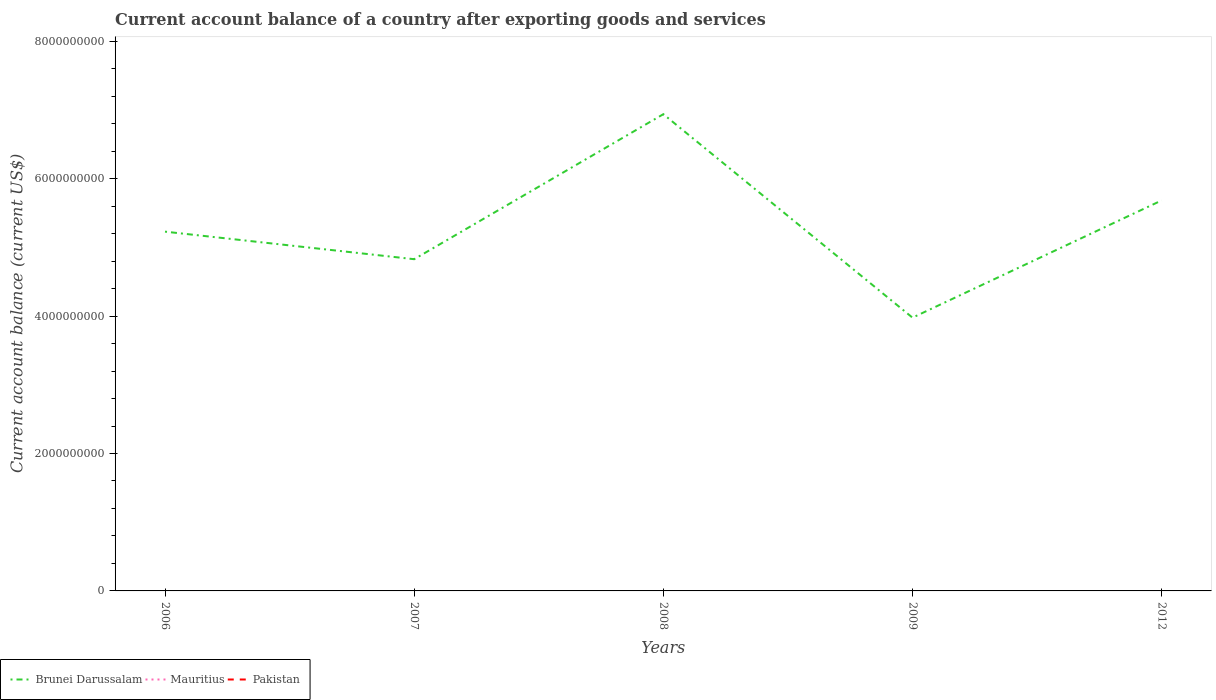How many different coloured lines are there?
Your response must be concise. 1. What is the total account balance in Brunei Darussalam in the graph?
Offer a terse response. -4.55e+08. What is the difference between the highest and the second highest account balance in Brunei Darussalam?
Your answer should be very brief. 2.96e+09. Is the account balance in Mauritius strictly greater than the account balance in Pakistan over the years?
Your response must be concise. No. How many lines are there?
Your answer should be compact. 1. How many years are there in the graph?
Your answer should be compact. 5. What is the difference between two consecutive major ticks on the Y-axis?
Offer a very short reply. 2.00e+09. Are the values on the major ticks of Y-axis written in scientific E-notation?
Provide a short and direct response. No. Does the graph contain any zero values?
Keep it short and to the point. Yes. How are the legend labels stacked?
Offer a very short reply. Horizontal. What is the title of the graph?
Make the answer very short. Current account balance of a country after exporting goods and services. What is the label or title of the X-axis?
Offer a very short reply. Years. What is the label or title of the Y-axis?
Your answer should be compact. Current account balance (current US$). What is the Current account balance (current US$) of Brunei Darussalam in 2006?
Offer a very short reply. 5.23e+09. What is the Current account balance (current US$) in Pakistan in 2006?
Your answer should be very brief. 0. What is the Current account balance (current US$) in Brunei Darussalam in 2007?
Offer a very short reply. 4.83e+09. What is the Current account balance (current US$) of Mauritius in 2007?
Your answer should be very brief. 0. What is the Current account balance (current US$) in Pakistan in 2007?
Ensure brevity in your answer.  0. What is the Current account balance (current US$) of Brunei Darussalam in 2008?
Your response must be concise. 6.94e+09. What is the Current account balance (current US$) in Brunei Darussalam in 2009?
Offer a very short reply. 3.98e+09. What is the Current account balance (current US$) of Pakistan in 2009?
Offer a terse response. 0. What is the Current account balance (current US$) of Brunei Darussalam in 2012?
Make the answer very short. 5.68e+09. What is the Current account balance (current US$) of Pakistan in 2012?
Your answer should be compact. 0. Across all years, what is the maximum Current account balance (current US$) in Brunei Darussalam?
Give a very brief answer. 6.94e+09. Across all years, what is the minimum Current account balance (current US$) of Brunei Darussalam?
Give a very brief answer. 3.98e+09. What is the total Current account balance (current US$) in Brunei Darussalam in the graph?
Provide a succinct answer. 2.67e+1. What is the total Current account balance (current US$) of Pakistan in the graph?
Offer a very short reply. 0. What is the difference between the Current account balance (current US$) in Brunei Darussalam in 2006 and that in 2007?
Make the answer very short. 4.01e+08. What is the difference between the Current account balance (current US$) of Brunei Darussalam in 2006 and that in 2008?
Your answer should be compact. -1.71e+09. What is the difference between the Current account balance (current US$) in Brunei Darussalam in 2006 and that in 2009?
Keep it short and to the point. 1.25e+09. What is the difference between the Current account balance (current US$) of Brunei Darussalam in 2006 and that in 2012?
Your response must be concise. -4.55e+08. What is the difference between the Current account balance (current US$) in Brunei Darussalam in 2007 and that in 2008?
Ensure brevity in your answer.  -2.11e+09. What is the difference between the Current account balance (current US$) in Brunei Darussalam in 2007 and that in 2009?
Offer a very short reply. 8.51e+08. What is the difference between the Current account balance (current US$) in Brunei Darussalam in 2007 and that in 2012?
Provide a short and direct response. -8.56e+08. What is the difference between the Current account balance (current US$) of Brunei Darussalam in 2008 and that in 2009?
Provide a succinct answer. 2.96e+09. What is the difference between the Current account balance (current US$) in Brunei Darussalam in 2008 and that in 2012?
Keep it short and to the point. 1.25e+09. What is the difference between the Current account balance (current US$) of Brunei Darussalam in 2009 and that in 2012?
Provide a succinct answer. -1.71e+09. What is the average Current account balance (current US$) of Brunei Darussalam per year?
Keep it short and to the point. 5.33e+09. What is the average Current account balance (current US$) in Pakistan per year?
Your answer should be compact. 0. What is the ratio of the Current account balance (current US$) in Brunei Darussalam in 2006 to that in 2007?
Offer a terse response. 1.08. What is the ratio of the Current account balance (current US$) in Brunei Darussalam in 2006 to that in 2008?
Offer a very short reply. 0.75. What is the ratio of the Current account balance (current US$) in Brunei Darussalam in 2006 to that in 2009?
Your response must be concise. 1.31. What is the ratio of the Current account balance (current US$) of Brunei Darussalam in 2006 to that in 2012?
Provide a succinct answer. 0.92. What is the ratio of the Current account balance (current US$) of Brunei Darussalam in 2007 to that in 2008?
Provide a succinct answer. 0.7. What is the ratio of the Current account balance (current US$) in Brunei Darussalam in 2007 to that in 2009?
Offer a very short reply. 1.21. What is the ratio of the Current account balance (current US$) in Brunei Darussalam in 2007 to that in 2012?
Ensure brevity in your answer.  0.85. What is the ratio of the Current account balance (current US$) of Brunei Darussalam in 2008 to that in 2009?
Provide a short and direct response. 1.74. What is the ratio of the Current account balance (current US$) in Brunei Darussalam in 2008 to that in 2012?
Make the answer very short. 1.22. What is the ratio of the Current account balance (current US$) of Brunei Darussalam in 2009 to that in 2012?
Ensure brevity in your answer.  0.7. What is the difference between the highest and the second highest Current account balance (current US$) of Brunei Darussalam?
Provide a succinct answer. 1.25e+09. What is the difference between the highest and the lowest Current account balance (current US$) of Brunei Darussalam?
Keep it short and to the point. 2.96e+09. 